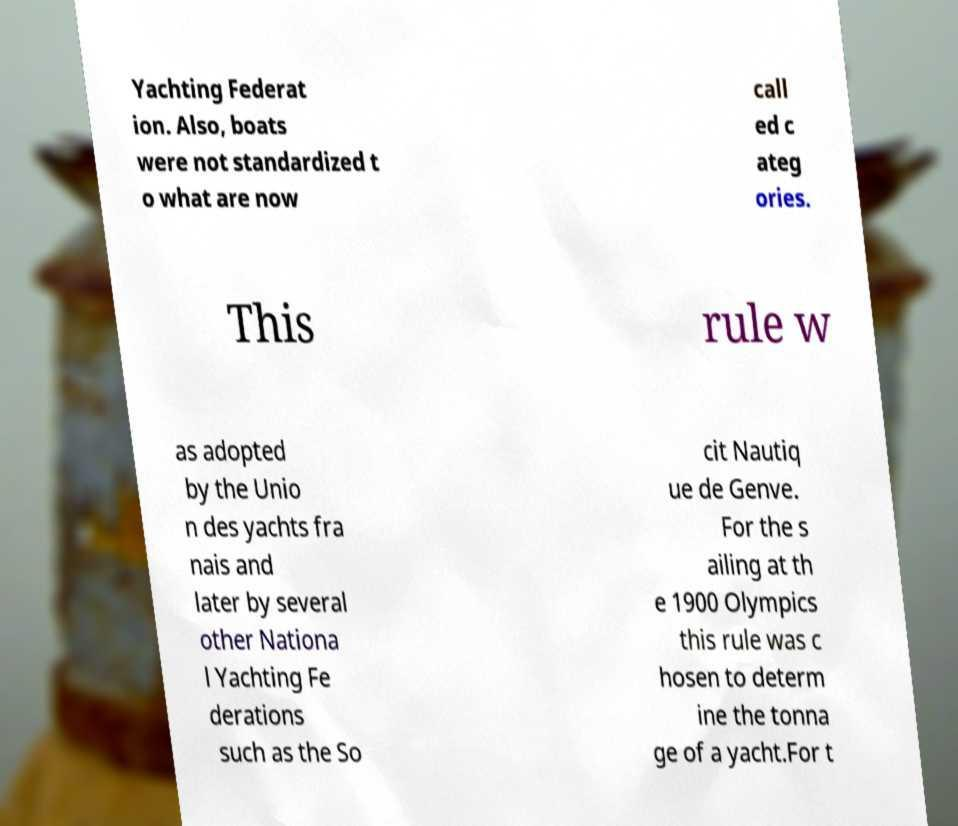I need the written content from this picture converted into text. Can you do that? Yachting Federat ion. Also, boats were not standardized t o what are now call ed c ateg ories. This rule w as adopted by the Unio n des yachts fra nais and later by several other Nationa l Yachting Fe derations such as the So cit Nautiq ue de Genve. For the s ailing at th e 1900 Olympics this rule was c hosen to determ ine the tonna ge of a yacht.For t 